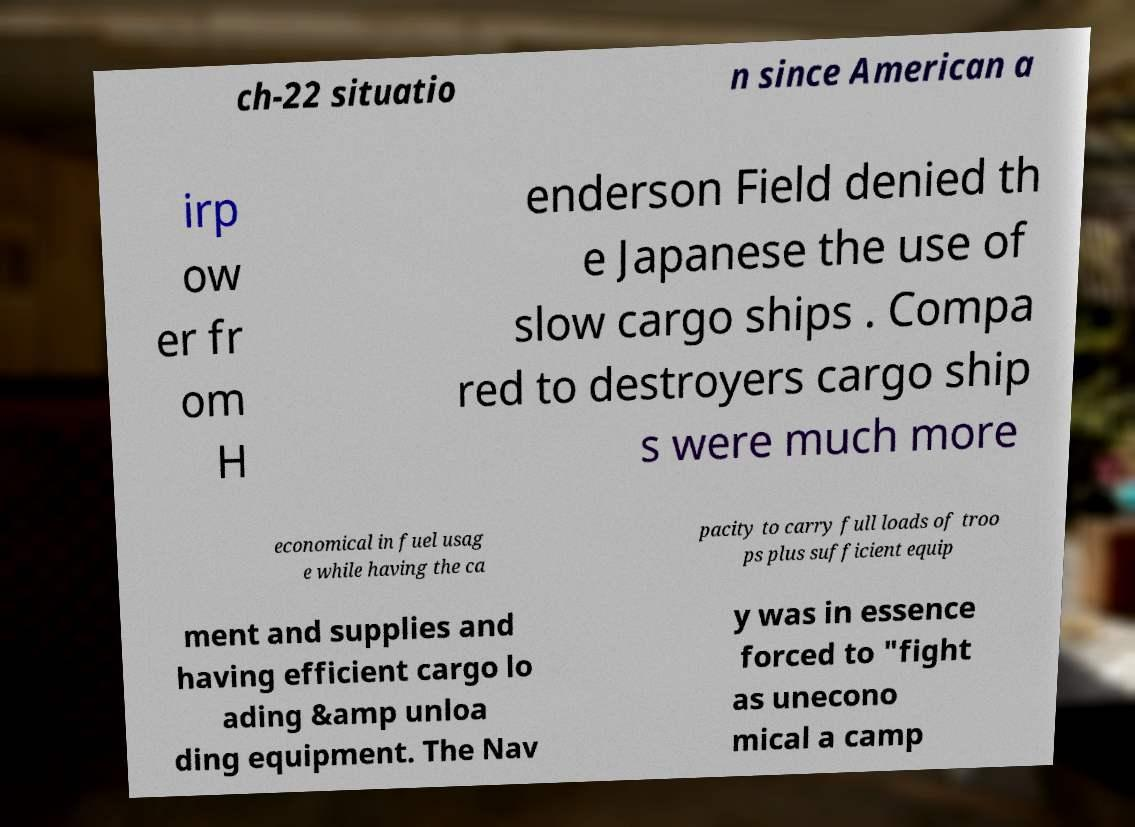Can you read and provide the text displayed in the image?This photo seems to have some interesting text. Can you extract and type it out for me? ch-22 situatio n since American a irp ow er fr om H enderson Field denied th e Japanese the use of slow cargo ships . Compa red to destroyers cargo ship s were much more economical in fuel usag e while having the ca pacity to carry full loads of troo ps plus sufficient equip ment and supplies and having efficient cargo lo ading &amp unloa ding equipment. The Nav y was in essence forced to "fight as unecono mical a camp 